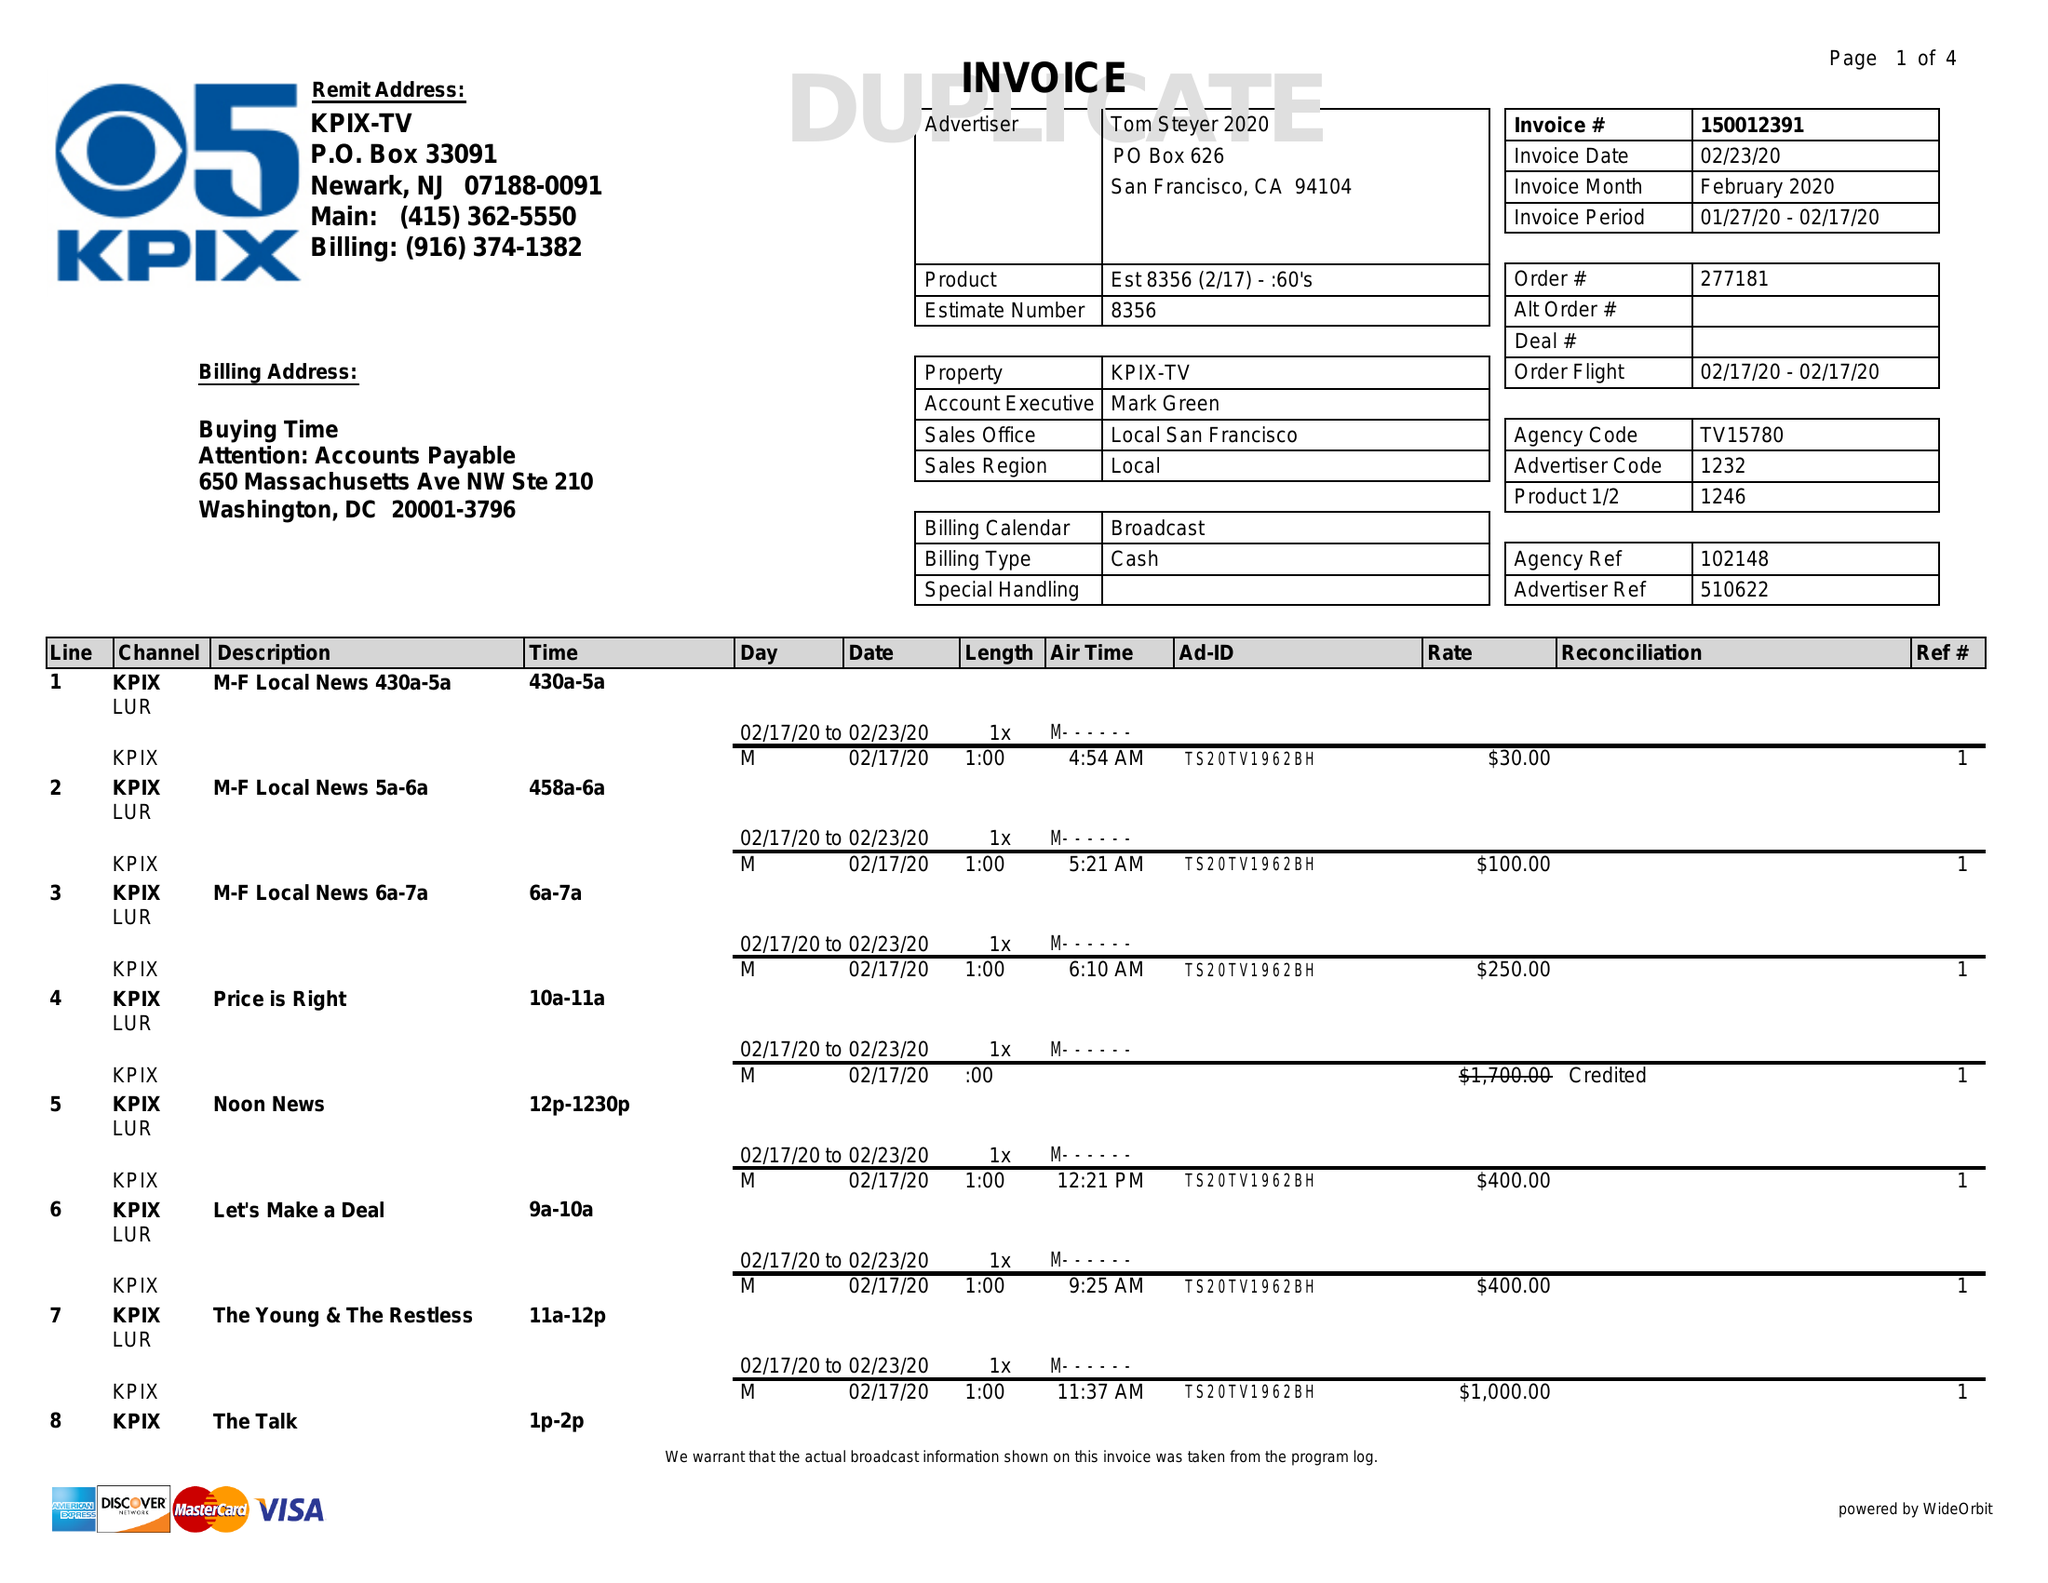What is the value for the advertiser?
Answer the question using a single word or phrase. TOM STEYER 2020 